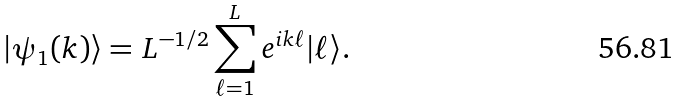Convert formula to latex. <formula><loc_0><loc_0><loc_500><loc_500>| \psi _ { 1 } ( k ) \rangle = L ^ { - 1 / 2 } \sum _ { \ell = 1 } ^ { L } e ^ { i k \ell } | \ell \rangle .</formula> 